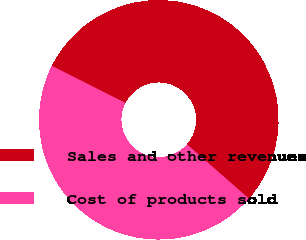Convert chart to OTSL. <chart><loc_0><loc_0><loc_500><loc_500><pie_chart><fcel>Sales and other revenues<fcel>Cost of products sold<nl><fcel>54.01%<fcel>45.99%<nl></chart> 